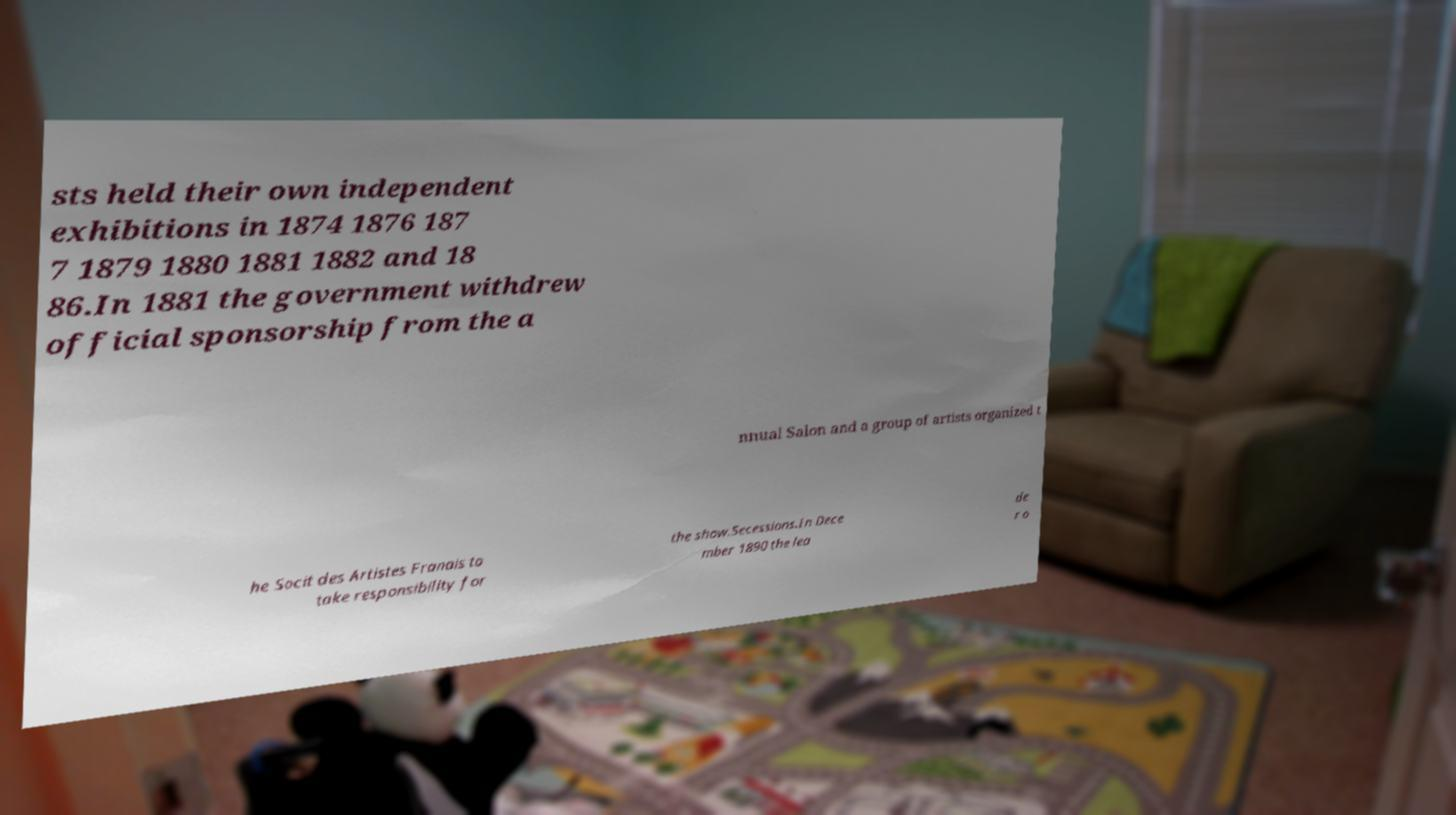Could you extract and type out the text from this image? sts held their own independent exhibitions in 1874 1876 187 7 1879 1880 1881 1882 and 18 86.In 1881 the government withdrew official sponsorship from the a nnual Salon and a group of artists organized t he Socit des Artistes Franais to take responsibility for the show.Secessions.In Dece mber 1890 the lea de r o 